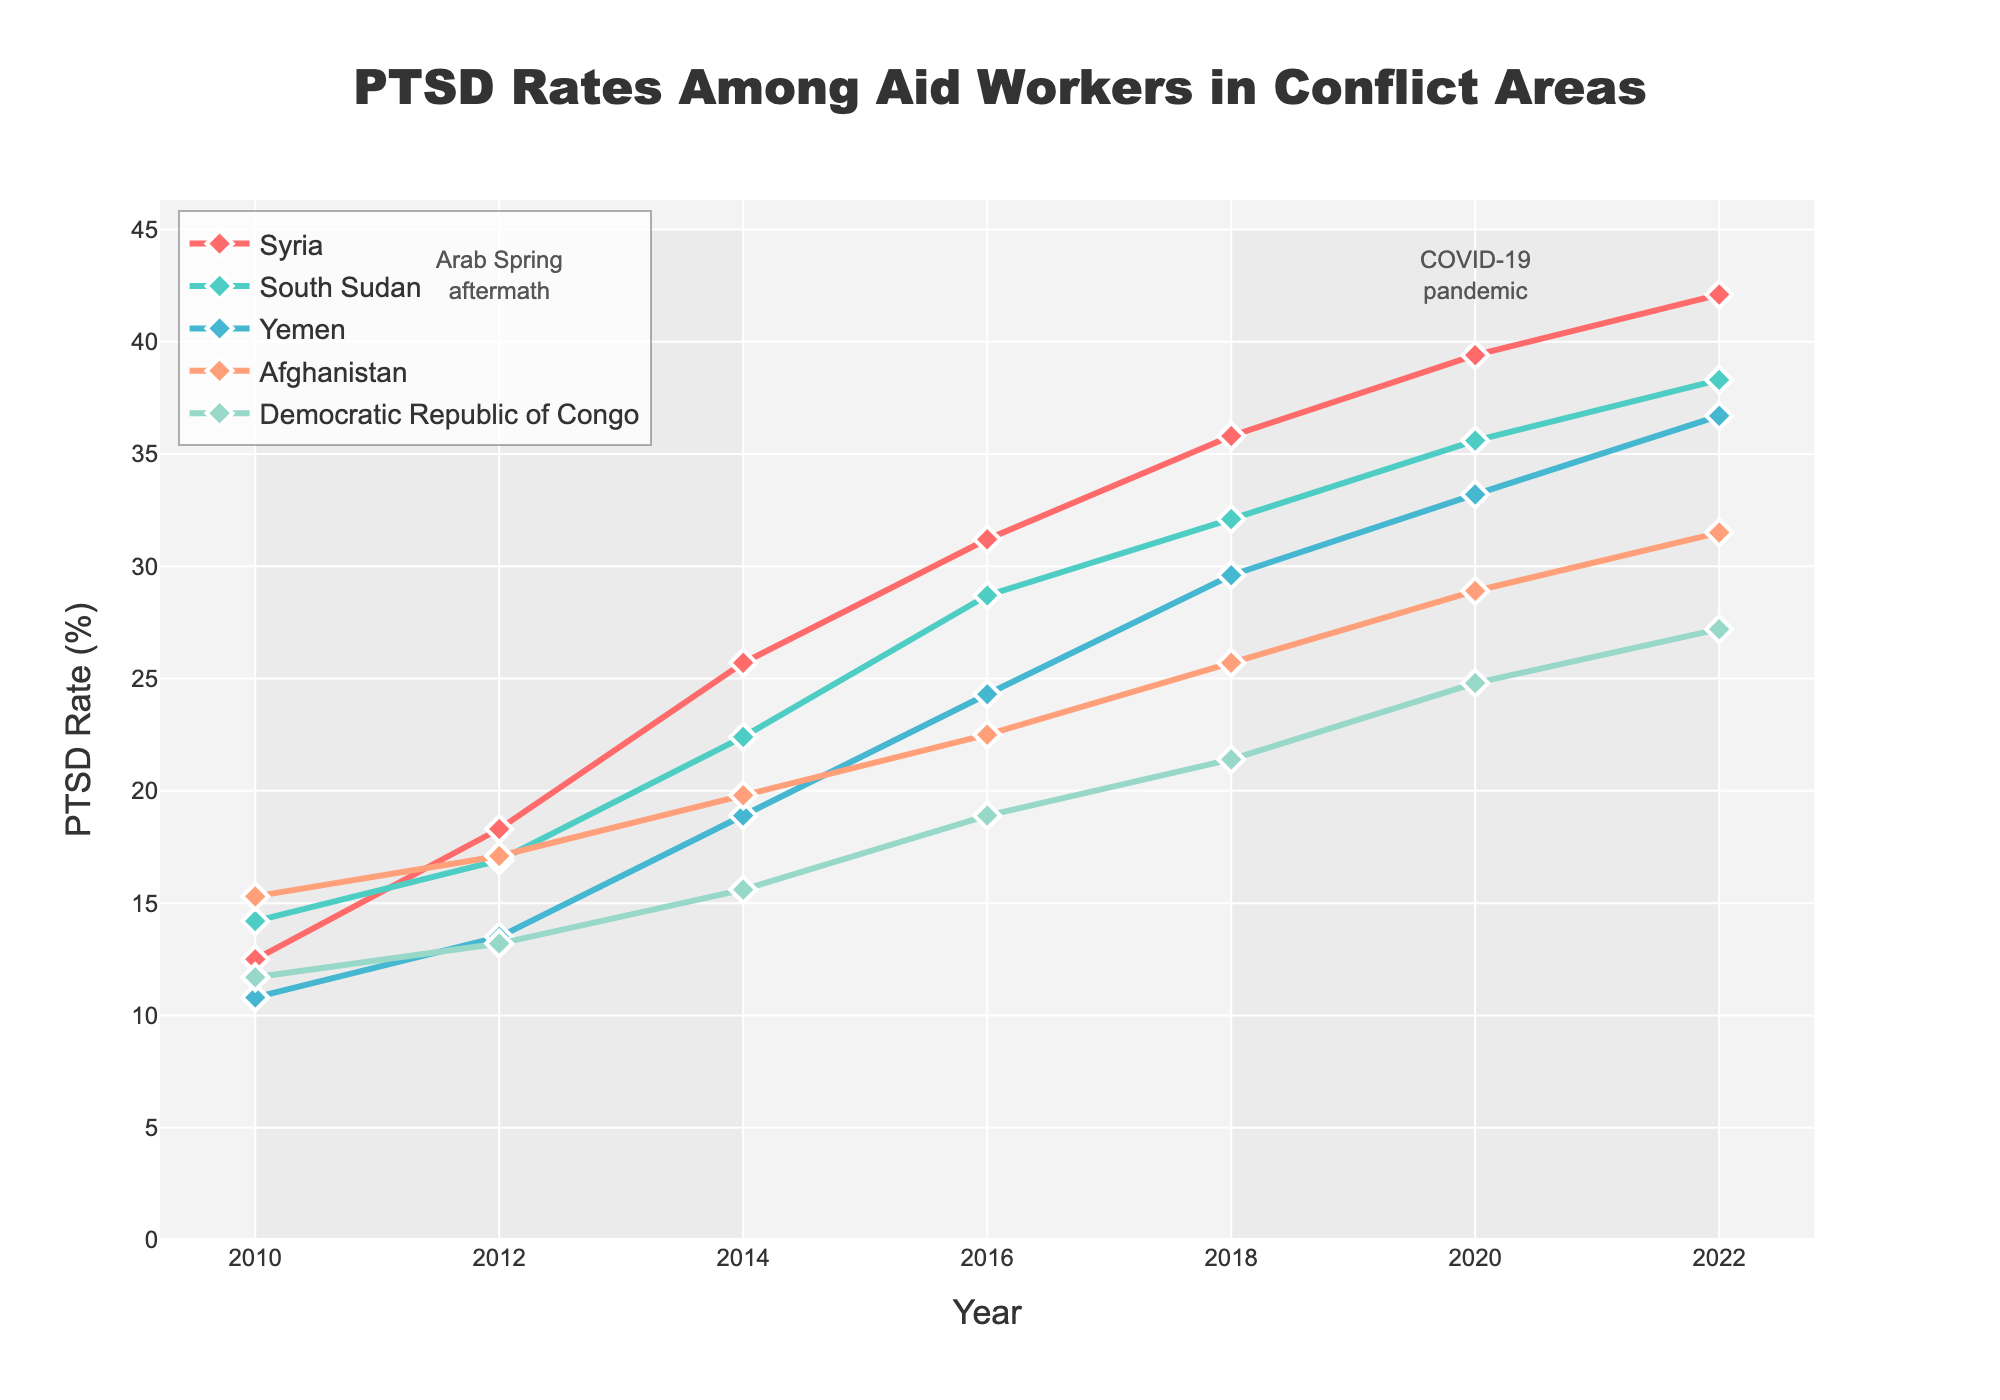What is the PTSD rate for aid workers in Syria in 2022? Identify the point at 2022 for Syria on the line chart; the y-value indicates the PTSD rate
Answer: 42.1% Compare the PTSD rates for aid workers in Yemen and Afghanistan in 2018. Which area had a higher rate? Find the points corresponding to Yemen and Afghanistan in 2018 and compare their y-values. Yemen: 29.6%, Afghanistan: 25.7%, so Yemen had a higher rate
Answer: Yemen What is the difference in PTSD rates between South Sudan and the Democratic Republic of Congo in 2020? Identify the 2020 y-values for both South Sudan and the Democratic Republic of Congo (35.6% and 24.8%, respectively). Subtract Congo's rate from South Sudan’s: 35.6 - 24.8
Answer: 10.8% For which country did the PTSD rate increase the most from 2010 to 2022? Calculate the difference in PTSD rates from 2010 to 2022 for each country and compare them. Syria: 42.1 - 12.5 = 29.6, South Sudan: 38.3 - 14.2 = 24.1, Yemen: 36.7 - 10.8 = 25.9, Afghanistan: 31.5 - 15.3 = 16.2, Congo: 27.2 - 11.7 = 15.5. The highest increase is in Syria
Answer: Syria What is the average PTSD rate of aid workers in Syria from 2010 to 2022? Add the PTSD rates for Syria from 2010 to 2022 and divide by the number of years: (12.5 + 18.3 + 25.7 + 31.2 + 35.8 + 39.4 + 42.1) / 7
Answer: 29.29% During the Arab Spring aftermath period (2010-2014), which country saw the largest increase in PTSD rates? Compute the PTSD rate change from 2010 to 2014 for each country. Syria: 25.7 - 12.5 = 13.2, South Sudan: 22.4 - 14.2 = 8.2, Yemen: 18.9 - 10.8 = 8.1, Afghanistan: 19.8 - 15.3 = 4.5, Congo: 15.6 - 11.7 = 3.9. Syria had the largest increase
Answer: Syria Examine the trend from 2016 to 2018. Which country had the smallest increase in PTSD rates? Calculate the rate change from 2016 to 2018 for each country. Syria: 35.8 - 31.2 = 4.6, South Sudan: 32.1 - 28.7 = 3.4, Yemen: 29.6 - 24.3 = 5.3, Afghanistan: 25.7 - 22.5 = 3.2, Congo: 21.4 - 18.9 = 2.5. The Democratic Republic of Congo had the smallest increase
Answer: Democratic Republic of Congo By how much did the PTSD rate for aid workers in Afghanistan increase during the COVID-19 pandemic period (2018-2022)? Calculate the change between 2018 and 2022 for Afghanistan: 31.5 - 25.7
Answer: 5.8% Compare the overall trends in PTSD rates between Syria and South Sudan from 2010 to 2022. Which country consistently had higher rates? Observe the two lines from 2010 to 2022. Syria’s line is consistently above South Sudan’s line indicating Syria had higher rates
Answer: Syria 